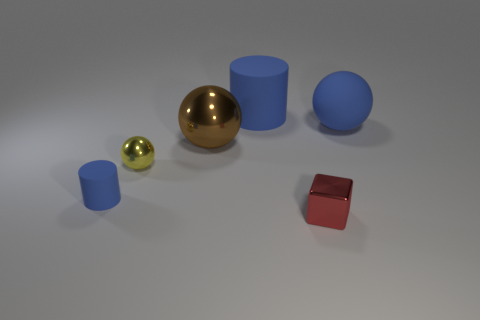What number of metallic objects are to the left of the big cylinder?
Make the answer very short. 2. Do the blue matte cylinder that is left of the large metallic thing and the ball to the right of the big blue cylinder have the same size?
Provide a short and direct response. No. There is a cylinder that is in front of the blue cylinder behind the blue matte thing in front of the tiny yellow metal thing; what is it made of?
Make the answer very short. Rubber. There is a red shiny thing; does it have the same size as the cylinder that is left of the large blue cylinder?
Provide a succinct answer. Yes. What size is the thing that is on the right side of the big cylinder and behind the red cube?
Make the answer very short. Large. Is there a large matte thing that has the same color as the tiny rubber cylinder?
Offer a terse response. Yes. There is a rubber cylinder that is behind the blue matte thing in front of the yellow metal sphere; what color is it?
Make the answer very short. Blue. Are there fewer red metallic things to the left of the brown metal sphere than things in front of the small blue matte thing?
Offer a very short reply. Yes. Do the yellow thing and the blue matte ball have the same size?
Ensure brevity in your answer.  No. What is the shape of the object that is to the left of the blue ball and behind the big brown shiny thing?
Your answer should be compact. Cylinder. 